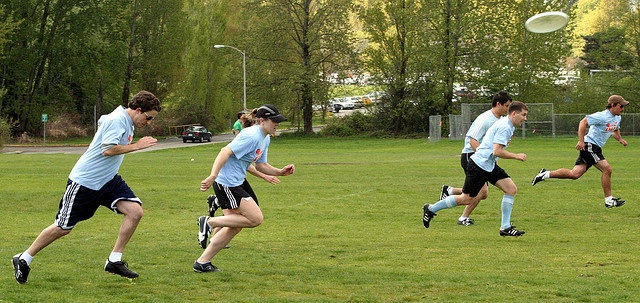Describe the objects in this image and their specific colors. I can see people in darkgreen, black, white, tan, and darkgray tones, people in darkgreen, olive, black, white, and gray tones, people in darkgreen, black, white, lightblue, and tan tones, people in darkgreen, black, brown, maroon, and lightgray tones, and people in darkgreen, white, black, olive, and gray tones in this image. 